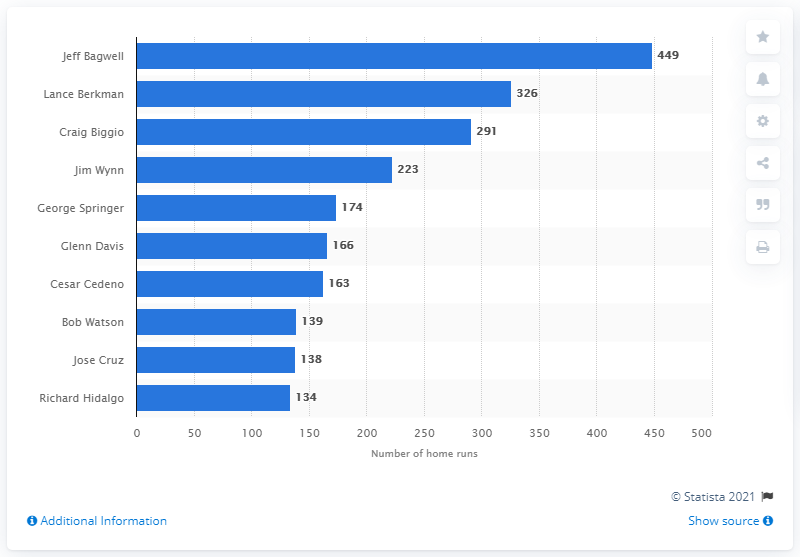Indicate a few pertinent items in this graphic. The Houston Astros franchise has seen many talented hitters over the years, but none have hit more home runs than Jeff Bagwell. I, Jeff Bagwell, have hit a total of 449 home runs, making me a powerhouse in the world of baseball. 